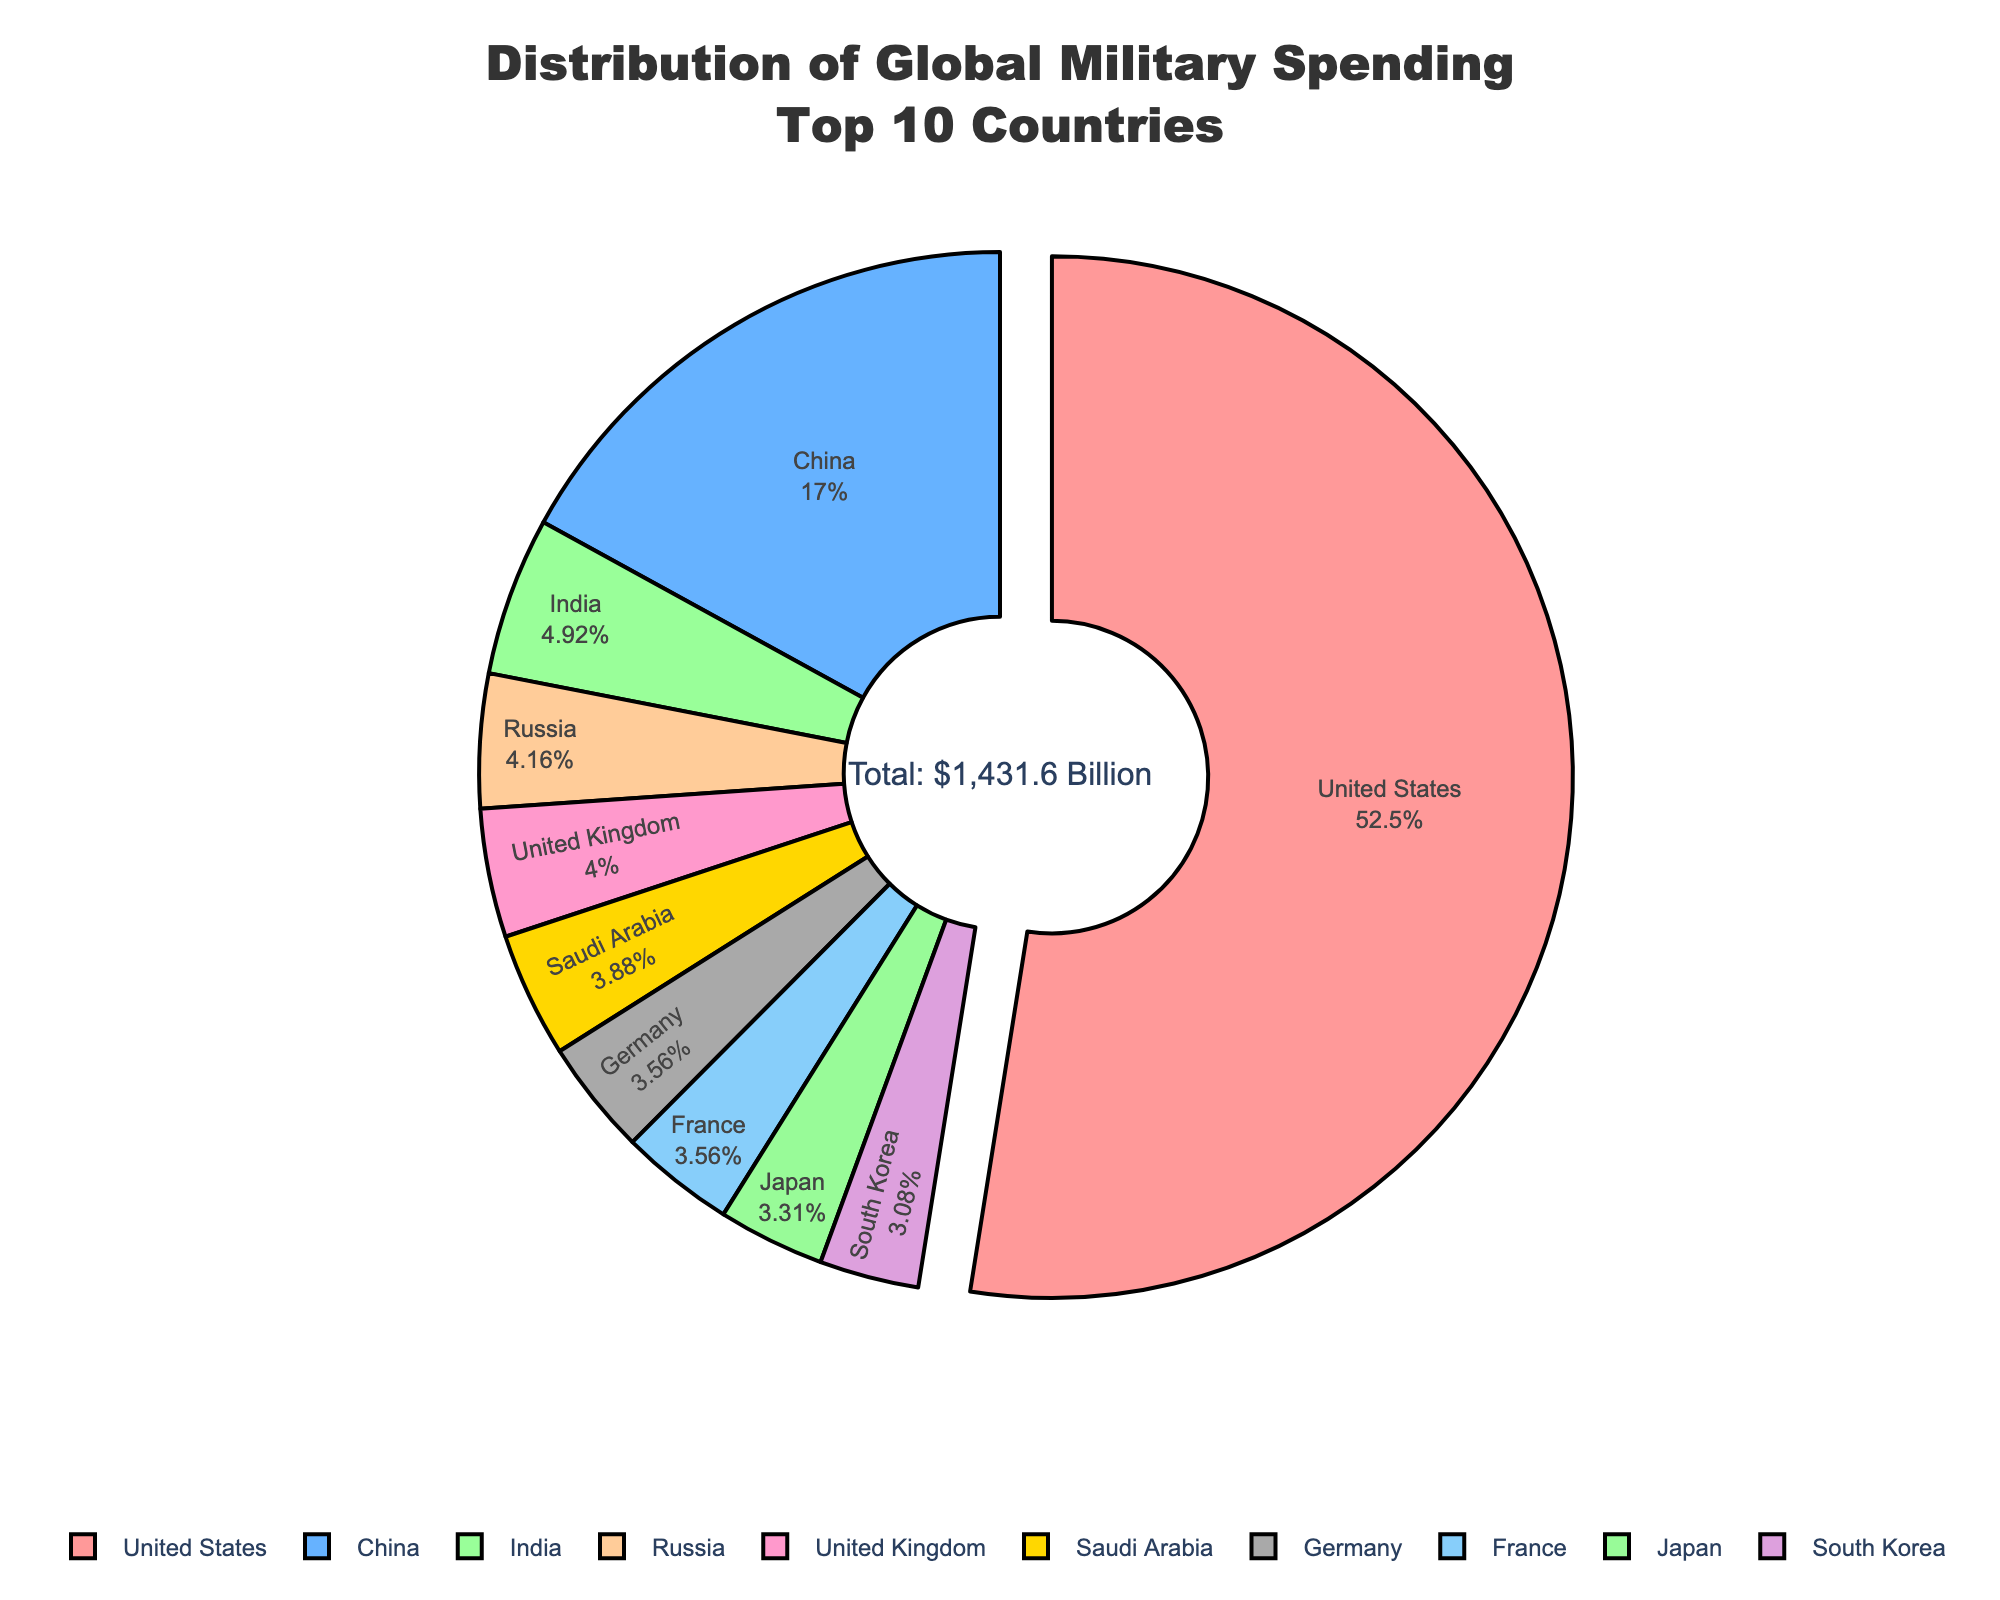Which country contributes the most to global military spending, and what percentage does it represent? The country that contributes the most is labeled distinctly with a prominent pulled-out slice and the largest percentage. The United States has a pulled-out slice indicating it is the highest contributor with 778 billion USD, which, looking at the percentage near the slice, represents the highest figure.
Answer: The United States, 54.3% How much more is the United States' military spending compared to China's? First, note the spending values for both the United States (778 billion USD) and China (252 billion USD). Subtract China's spending from that of the United States: 778 - 252 = 526 billion USD.
Answer: 526 billion USD Which country has the smallest military spending and what percentage of the total does it represent? The country with the smallest slice visually corresponds to the smallest value. South Korea spends the least with 45.7 billion USD, and by looking at the percentage label next to it, it represents the smallest percentage.
Answer: South Korea, 3.2% How does the combined spending of India and Russia compare to the spending of the United States? Add the spending values of India (72.9 billion USD) and Russia (61.7 billion USD) to find their combined spending: 72.9 + 61.7 = 134.6 billion USD. Then compare this to the United States' spending of 778 billion USD to see that the combined value is much less.
Answer: Combined spending is 643.4 billion USD less What is the percentage difference in military spending between Saudi Arabia and the United Kingdom? Find the spending values for Saudi Arabia (57.5 billion USD) and the United Kingdom (59.2 billion USD). Calculate the difference: 59.2 - 57.5 = 1.7 billion USD. Then, divide this difference by the UK's spending and multiply by 100 to find the percentage: (1.7 / 59.2) * 100 ≈ 2.87%
Answer: Approximately 2.87% Combining the military spending of Germany and France, what rank would their total hold compared to individual countries' spending? Add Germany's spending (52.8 billion USD) and France's spending (52.7 billion USD) to get the total: 52.8 + 52.7 = 105.5 billion USD. Comparing this to the other countries' data, their combined total would rank third after the United States (778 billion USD) and China (252 billion USD).
Answer: Third What is the difference in percentage points of global military spending between Japan and South Korea? Find the percentage values for Japan and South Korea from the chart and subtract them: Japan's percentage is given as 3.4%, and South Korea's is 3.2%. The difference is 3.4% - 3.2% = 0.2 percentage points.
Answer: 0.2 percentage points 